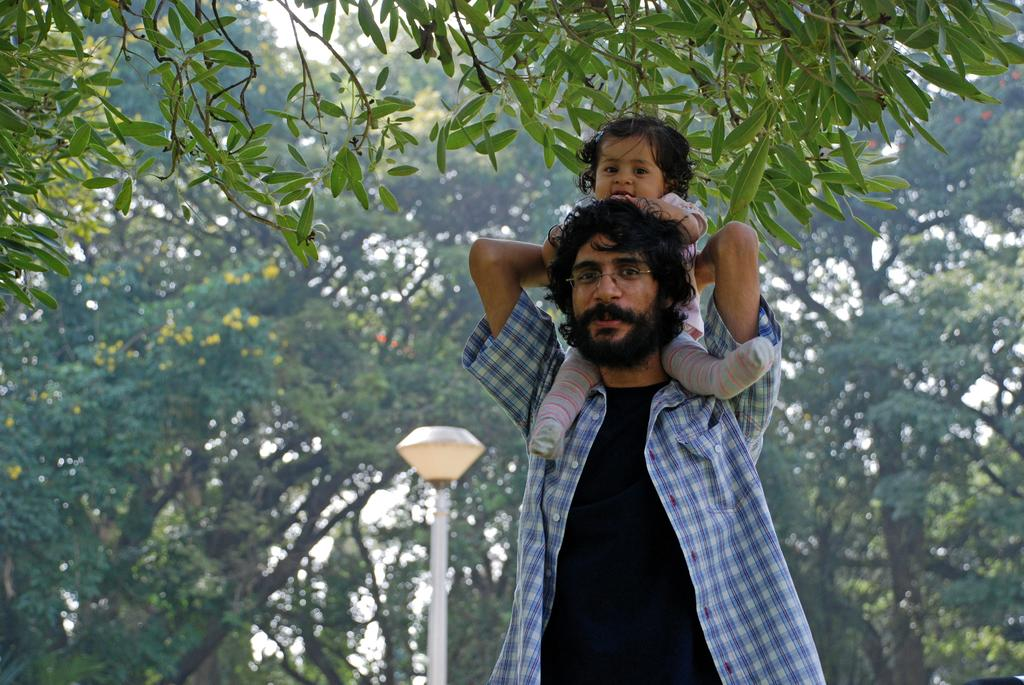Who is present in the image? There is a man and a baby in the image. What can be seen in the background of the image? There is a pole, a light, and trees in the background of the image. What type of sign is the baby holding in the image? There is no sign present in the image; the baby is not holding anything. 